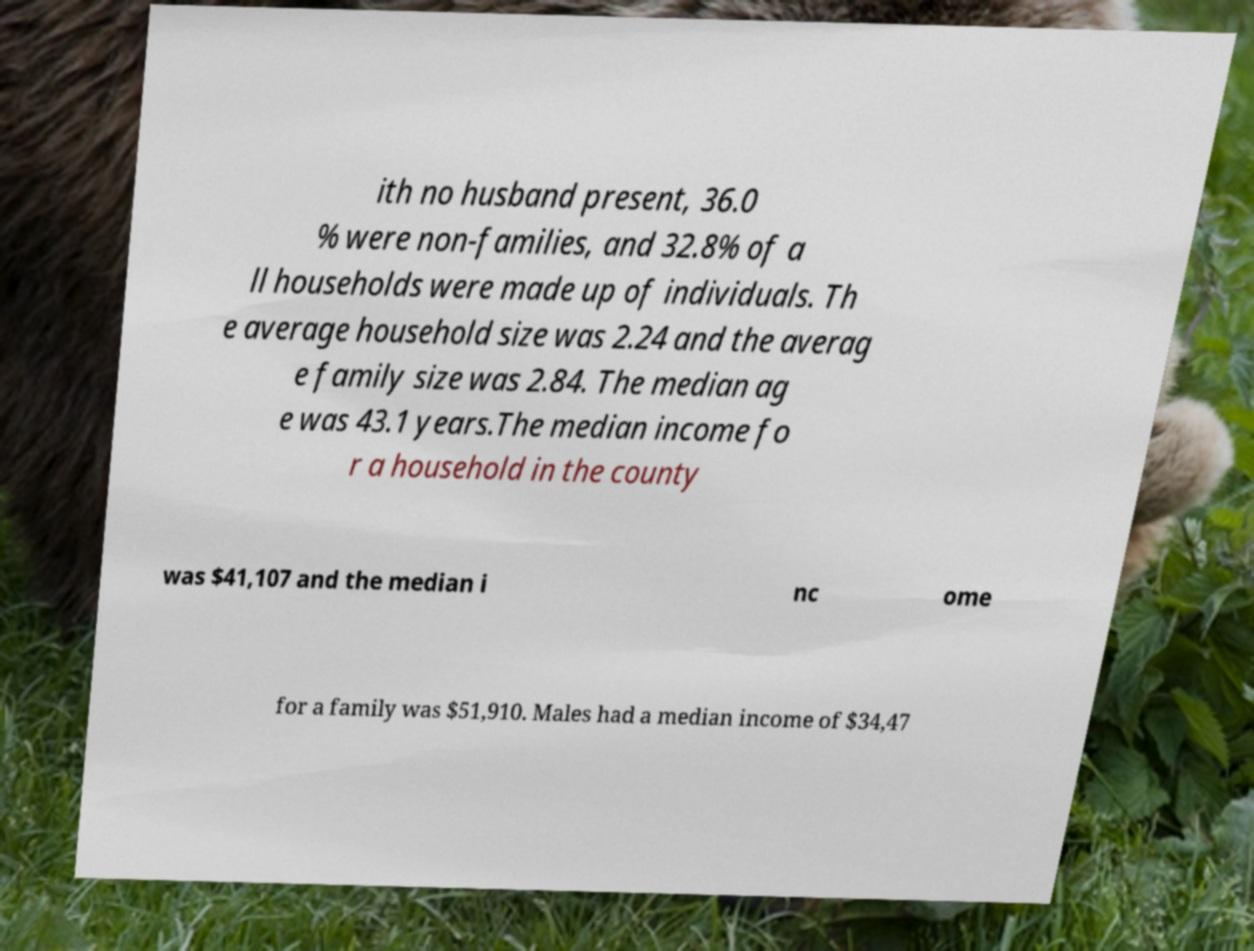I need the written content from this picture converted into text. Can you do that? ith no husband present, 36.0 % were non-families, and 32.8% of a ll households were made up of individuals. Th e average household size was 2.24 and the averag e family size was 2.84. The median ag e was 43.1 years.The median income fo r a household in the county was $41,107 and the median i nc ome for a family was $51,910. Males had a median income of $34,47 